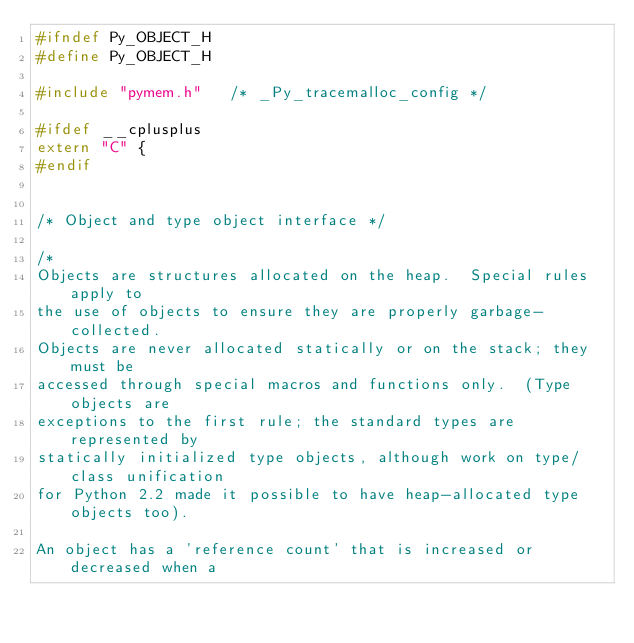<code> <loc_0><loc_0><loc_500><loc_500><_C_>#ifndef Py_OBJECT_H
#define Py_OBJECT_H

#include "pymem.h"   /* _Py_tracemalloc_config */

#ifdef __cplusplus
extern "C" {
#endif


/* Object and type object interface */

/*
Objects are structures allocated on the heap.  Special rules apply to
the use of objects to ensure they are properly garbage-collected.
Objects are never allocated statically or on the stack; they must be
accessed through special macros and functions only.  (Type objects are
exceptions to the first rule; the standard types are represented by
statically initialized type objects, although work on type/class unification
for Python 2.2 made it possible to have heap-allocated type objects too).

An object has a 'reference count' that is increased or decreased when a</code> 